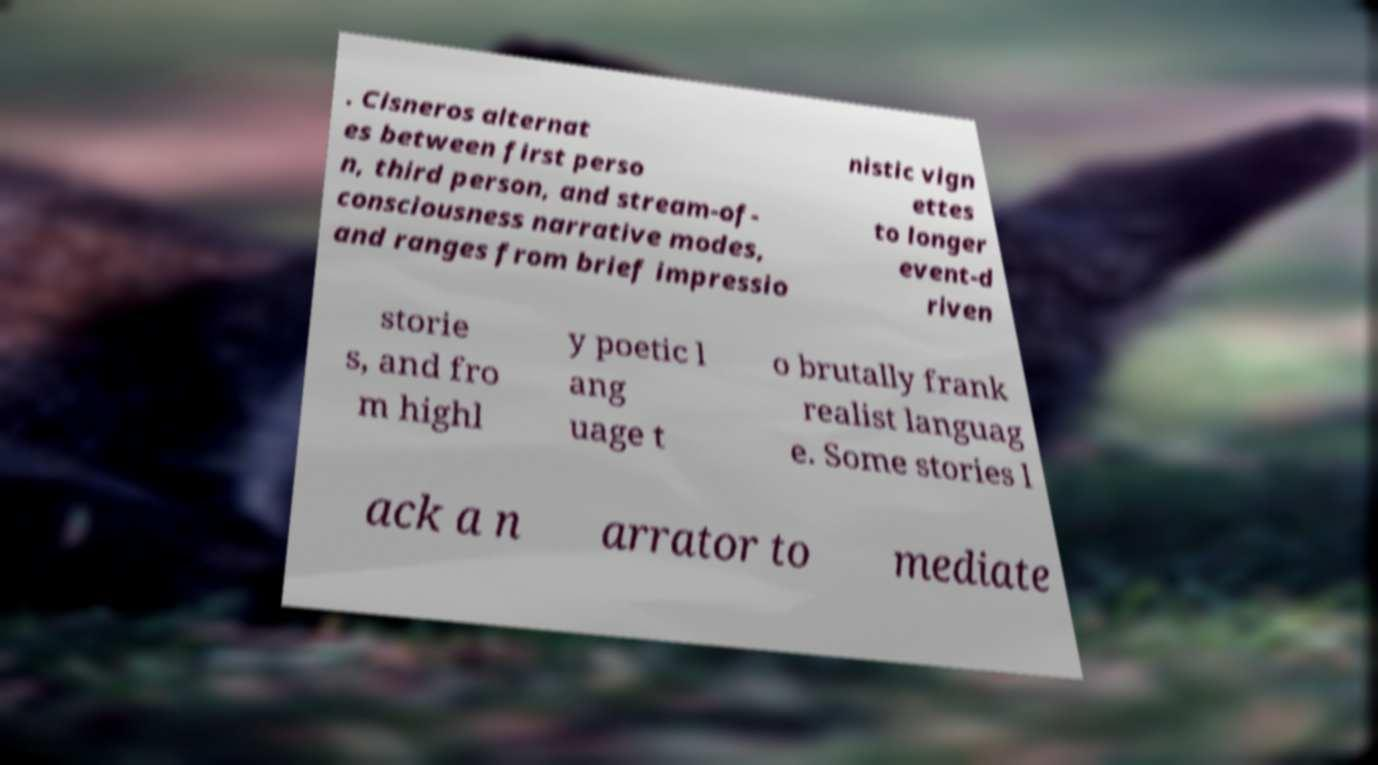For documentation purposes, I need the text within this image transcribed. Could you provide that? . Cisneros alternat es between first perso n, third person, and stream-of- consciousness narrative modes, and ranges from brief impressio nistic vign ettes to longer event-d riven storie s, and fro m highl y poetic l ang uage t o brutally frank realist languag e. Some stories l ack a n arrator to mediate 